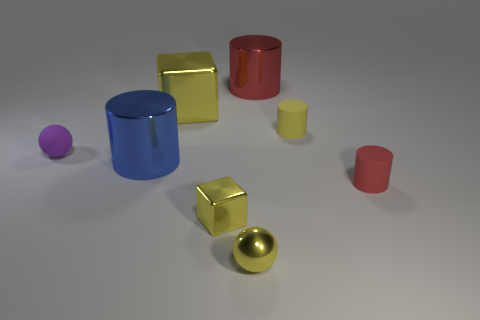What is the shape of the yellow metallic object that is the same size as the yellow sphere? cube 